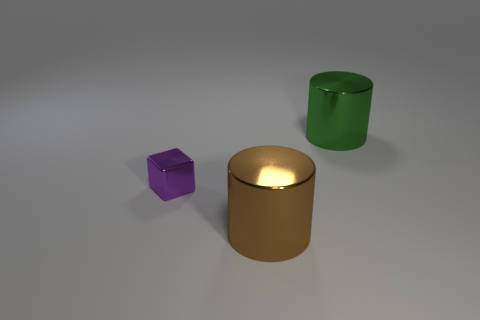Is the number of metal objects that are in front of the cube greater than the number of cylinders that are right of the large green metal object?
Offer a very short reply. Yes. How many rubber objects are cyan objects or small purple things?
Provide a succinct answer. 0. What material is the big cylinder in front of the tiny thing?
Keep it short and to the point. Metal. How many things are either purple shiny blocks or large metallic cylinders right of the big brown metal cylinder?
Offer a very short reply. 2. What is the shape of the thing that is the same size as the green metallic cylinder?
Make the answer very short. Cylinder. What number of tiny metal objects have the same color as the small shiny cube?
Make the answer very short. 0. Is the material of the big cylinder behind the large brown shiny object the same as the cube?
Ensure brevity in your answer.  Yes. There is a green thing; what shape is it?
Keep it short and to the point. Cylinder. What number of purple things are either big things or small cubes?
Offer a very short reply. 1. What number of other things are there of the same material as the green thing
Offer a terse response. 2. 